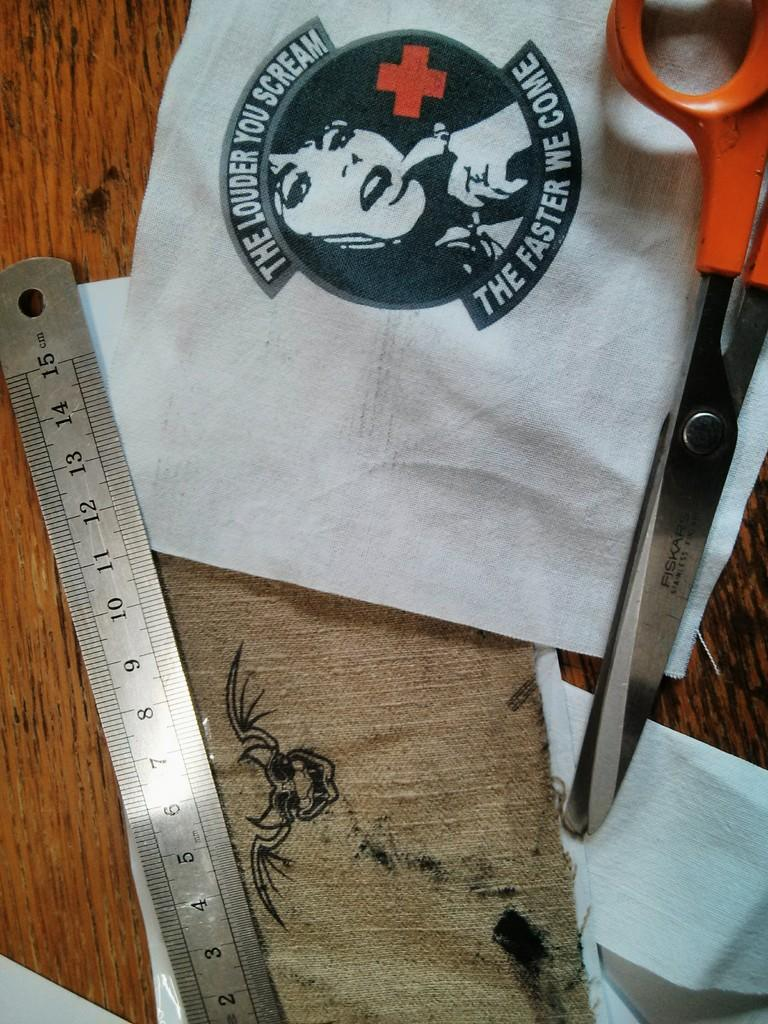<image>
Offer a succinct explanation of the picture presented. A piece of art that says the louder you scream the faster we come. 